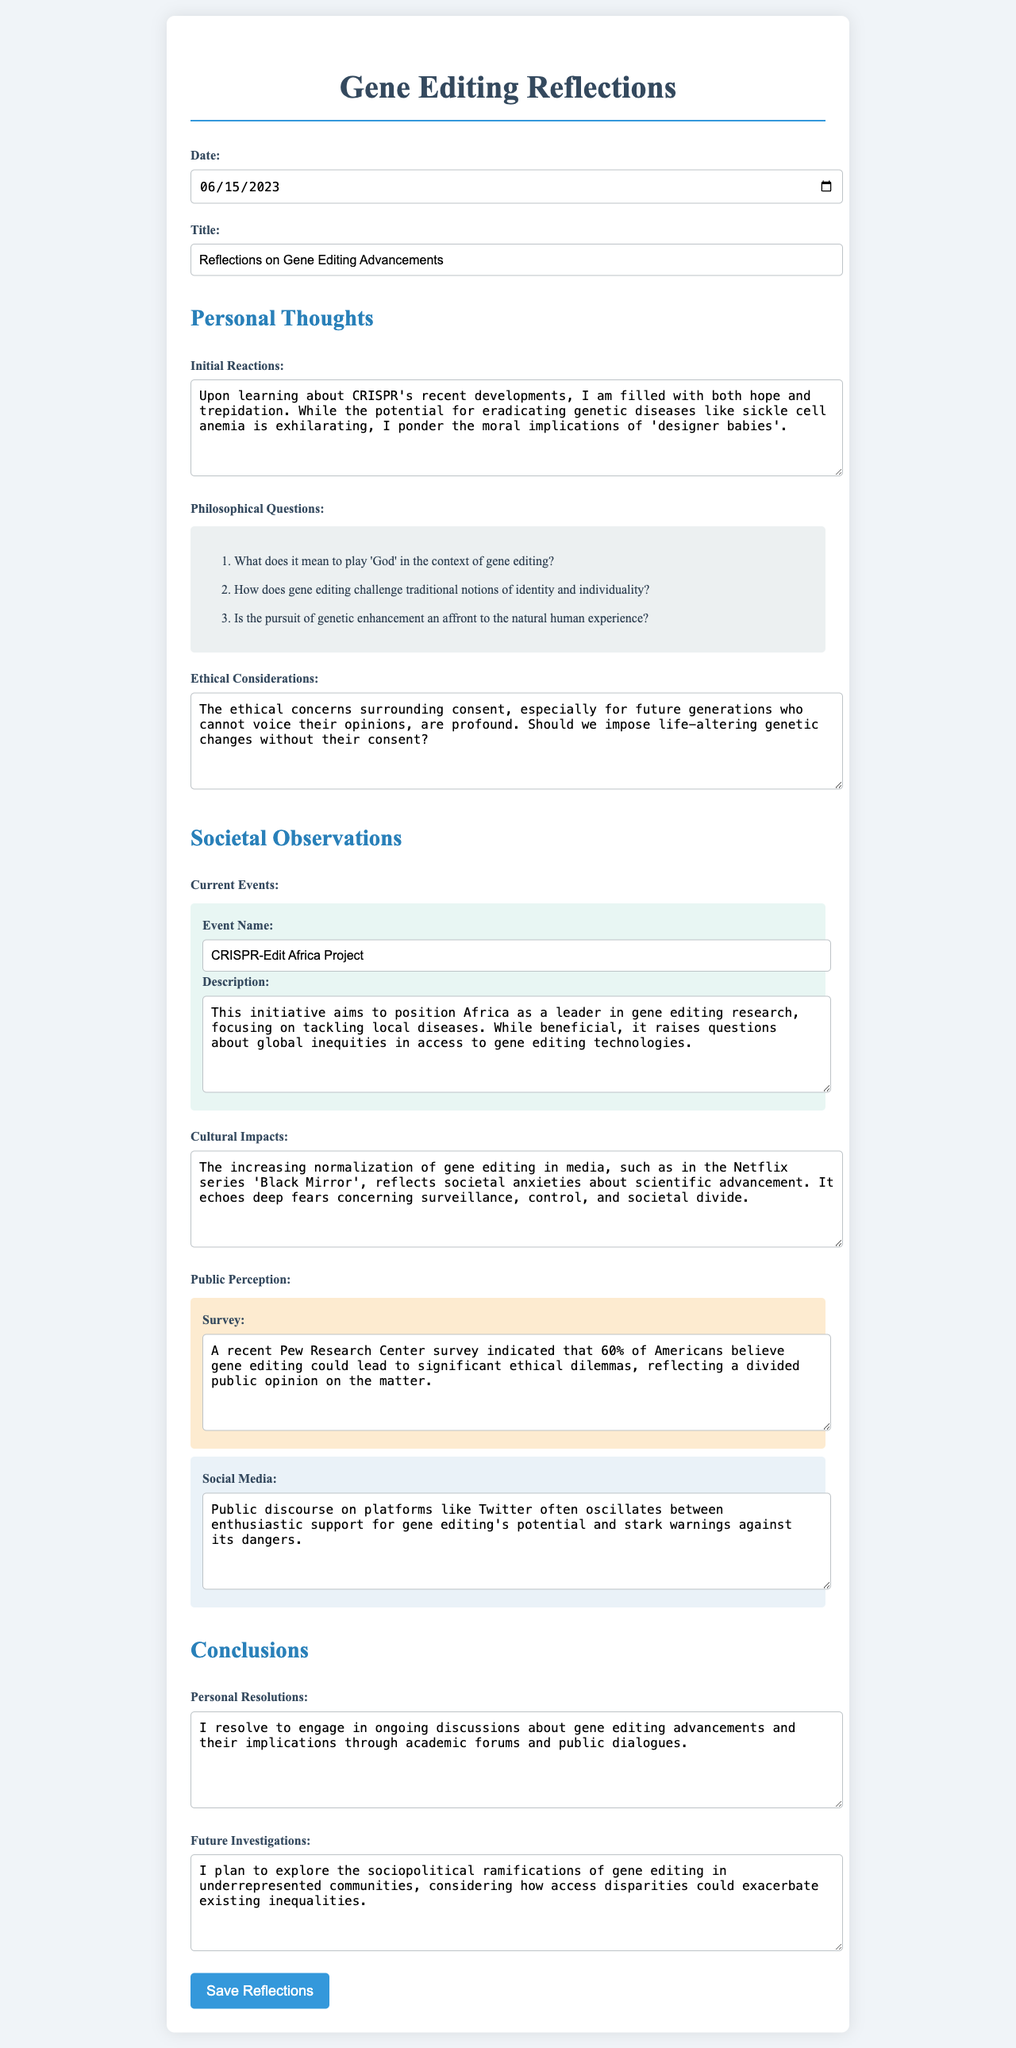What is the date of the reflections? The date is specified in the input field for the date section of the form.
Answer: 2023-06-15 What is the title of the journal entry? The title is indicated in the input field for the title section of the form.
Answer: Reflections on Gene Editing Advancements What are the initial reactions to CRISPR's developments? The initial reactions are provided in the textarea for initial reactions.
Answer: Upon learning about CRISPR's recent developments, I am filled with both hope and trepidation Which ethical concern is highlighted in the journal? The ethical concerns are discussed in the section for ethical considerations.
Answer: The ethical concerns surrounding consent, especially for future generations who cannot voice their opinions, are profound What is the name of the current event mentioned? The name of the current event is given in the event section of the form.
Answer: CRISPR-Edit Africa Project How does the document reflect societal observations? Societal observations are represented in several sections of the form that discuss current events, cultural impacts, and public perception.
Answer: Cultural impacts and public perception are highlighted How many philosophical questions are listed? The philosophical questions are provided in a numbered list.
Answer: Three What is one of the proposed future investigations? Future investigations are specified in the textarea for future investigations.
Answer: I plan to explore the sociopolitical ramifications of gene editing in underrepresented communities 